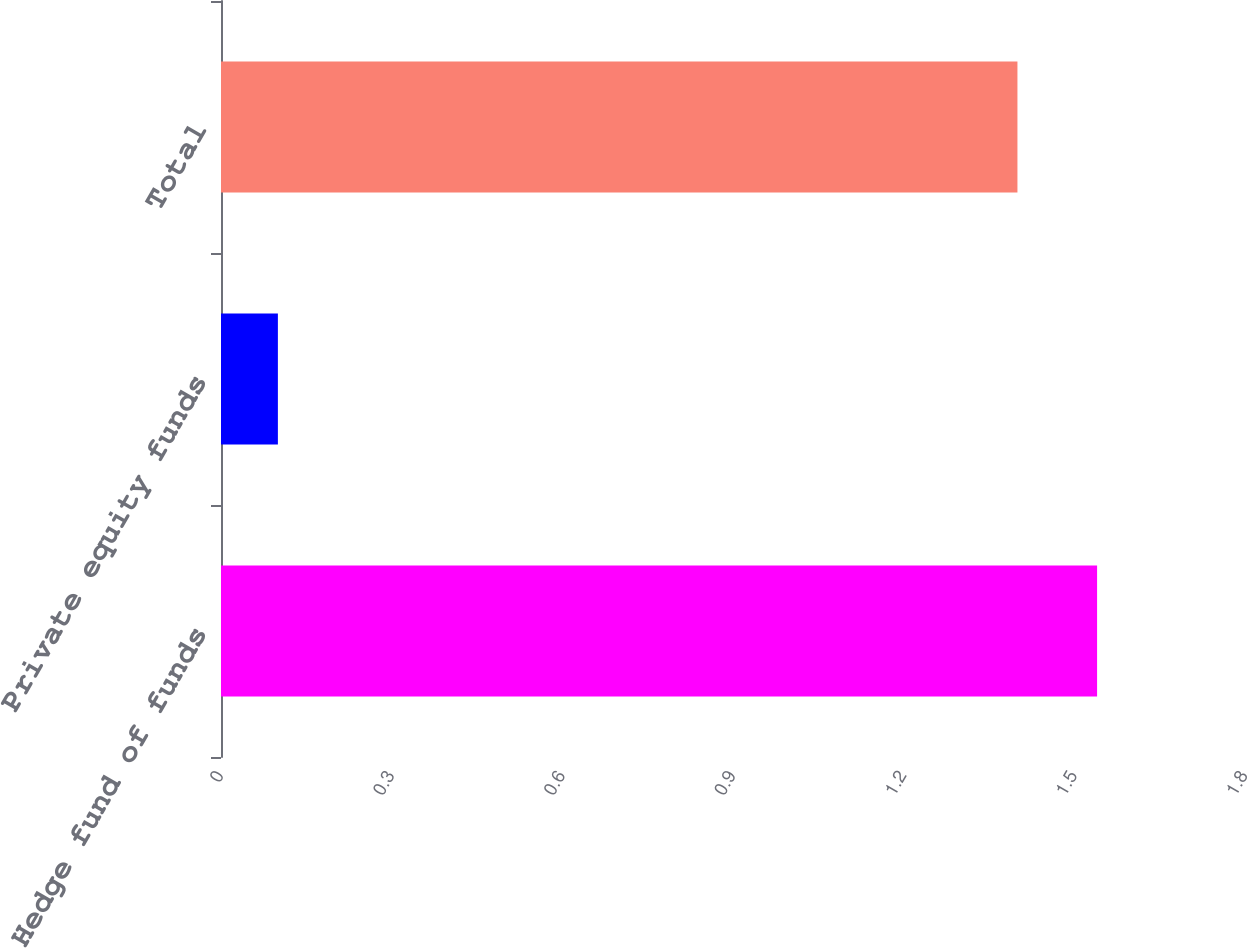<chart> <loc_0><loc_0><loc_500><loc_500><bar_chart><fcel>Hedge fund of funds<fcel>Private equity funds<fcel>Total<nl><fcel>1.54<fcel>0.1<fcel>1.4<nl></chart> 